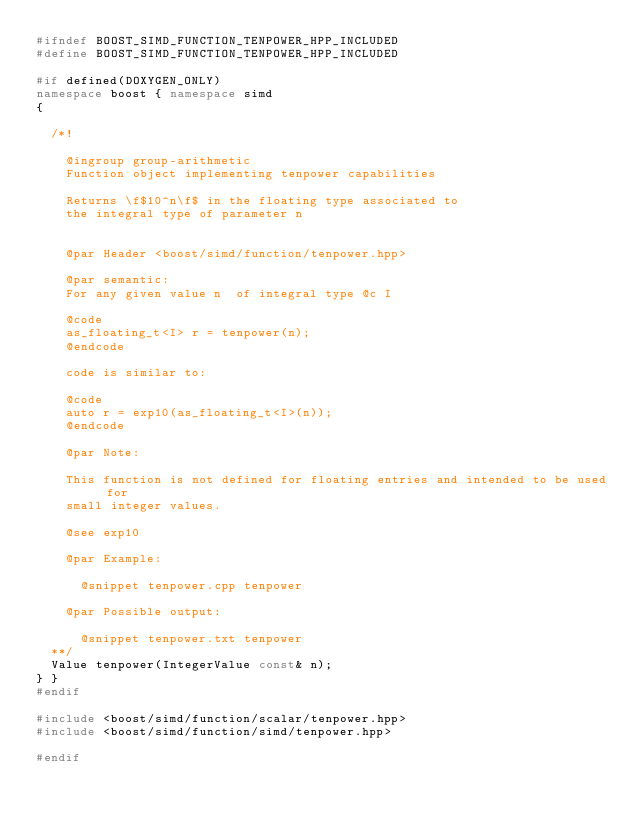<code> <loc_0><loc_0><loc_500><loc_500><_C++_>#ifndef BOOST_SIMD_FUNCTION_TENPOWER_HPP_INCLUDED
#define BOOST_SIMD_FUNCTION_TENPOWER_HPP_INCLUDED

#if defined(DOXYGEN_ONLY)
namespace boost { namespace simd
{

  /*!

    @ingroup group-arithmetic
    Function object implementing tenpower capabilities

    Returns \f$10^n\f$ in the floating type associated to
    the integral type of parameter n


    @par Header <boost/simd/function/tenpower.hpp>

    @par semantic:
    For any given value n  of integral type @c I

    @code
    as_floating_t<I> r = tenpower(n);
    @endcode

    code is similar to:

    @code
    auto r = exp10(as_floating_t<I>(n));
    @endcode

    @par Note:

    This function is not defined for floating entries and intended to be used for
    small integer values.

    @see exp10

    @par Example:

      @snippet tenpower.cpp tenpower

    @par Possible output:

      @snippet tenpower.txt tenpower
  **/
  Value tenpower(IntegerValue const& n);
} }
#endif

#include <boost/simd/function/scalar/tenpower.hpp>
#include <boost/simd/function/simd/tenpower.hpp>

#endif
</code> 